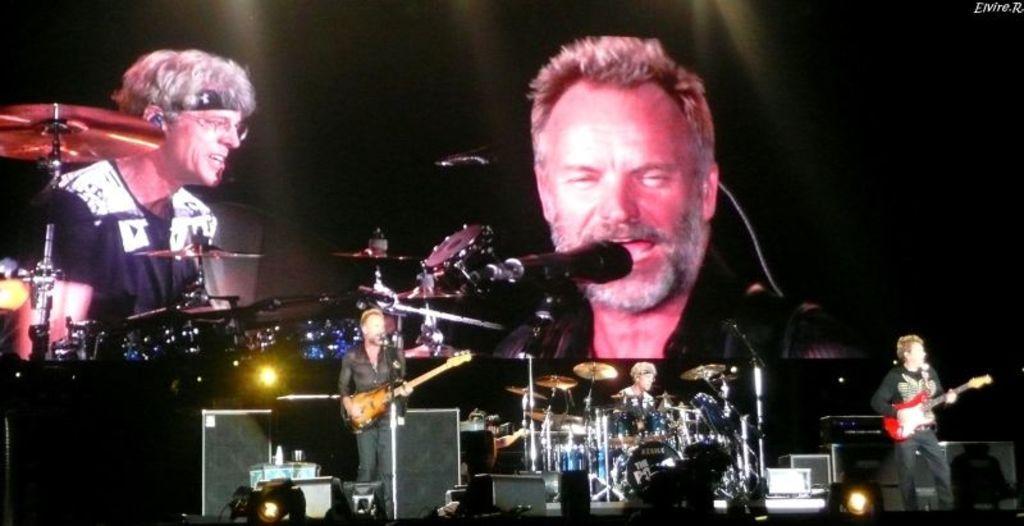How would you summarize this image in a sentence or two? a person is standing playing guitar in the center. and at the right corner there is another person playing a red color guitar. behind them there are drums and a person is playing them. behind them there is a projector displayed on which these people are being displayed. 